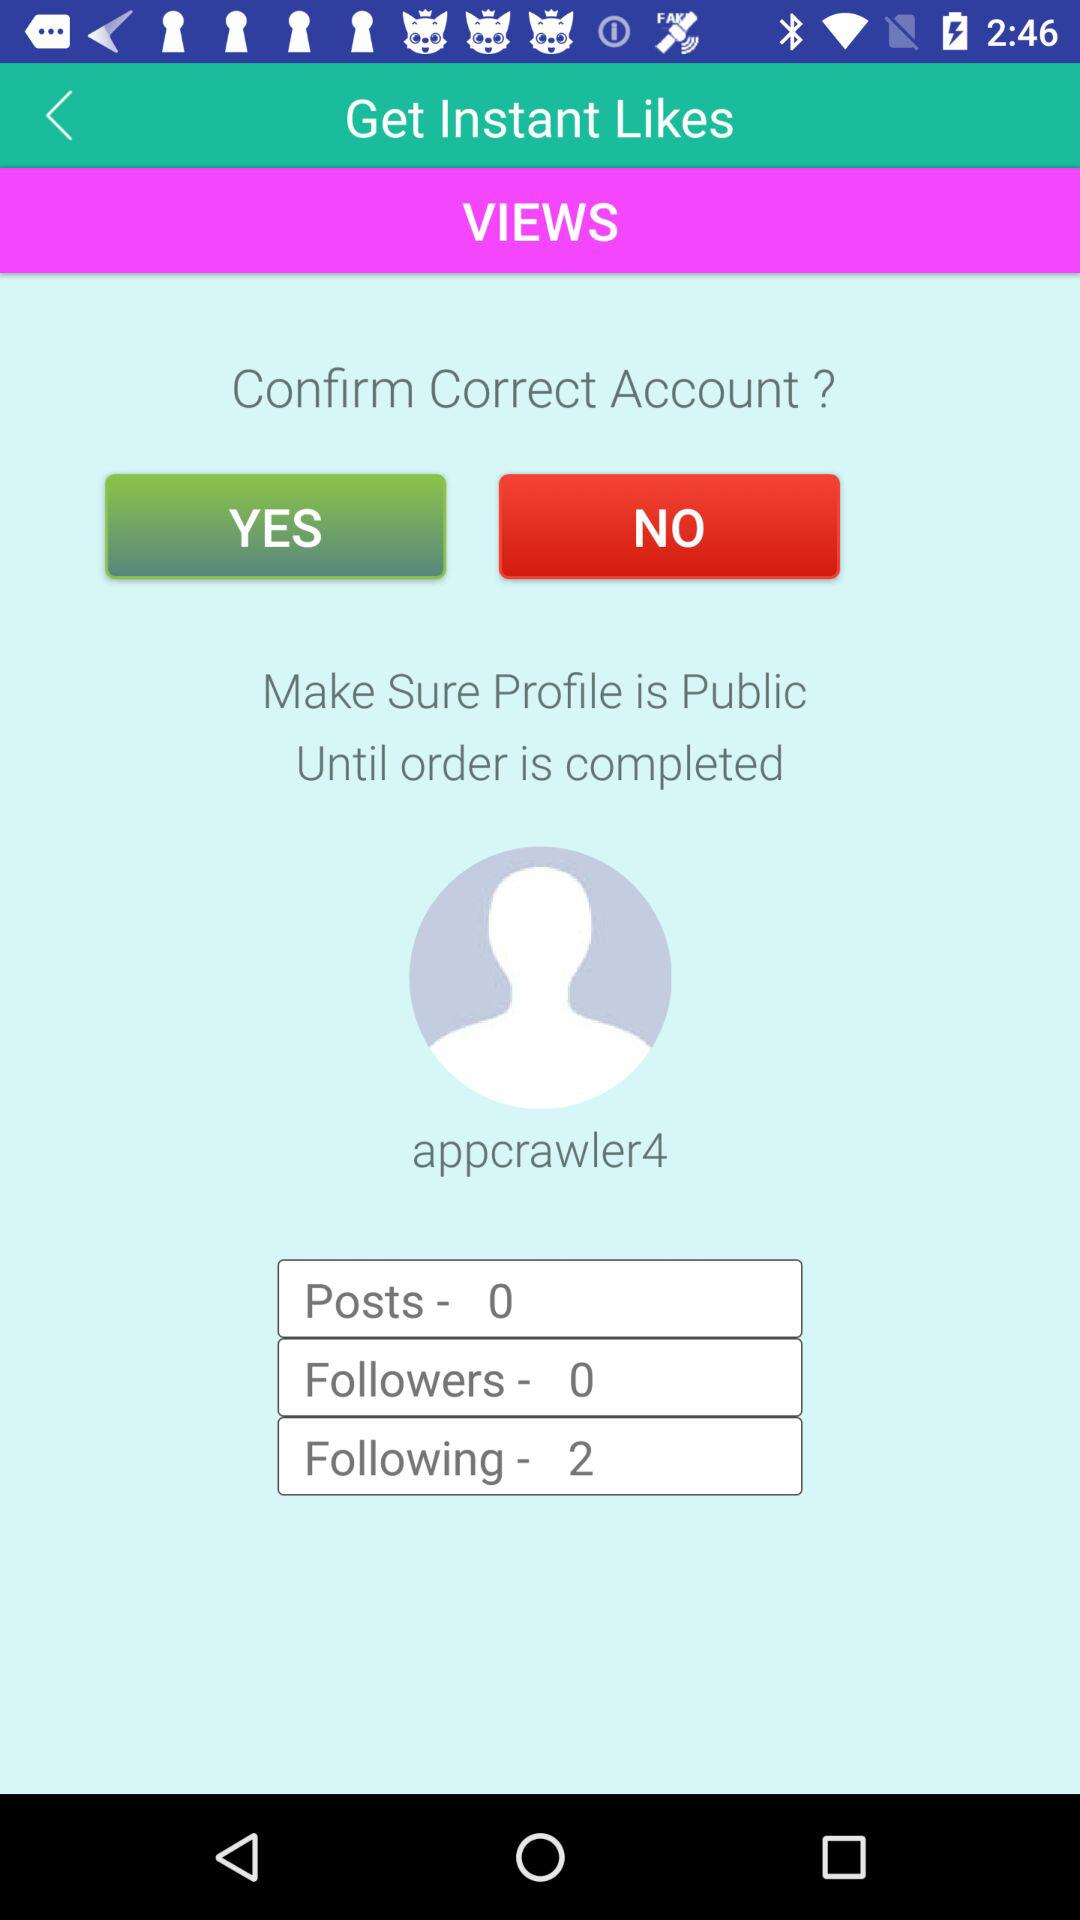What is the username? The username is "appcrawler4". 